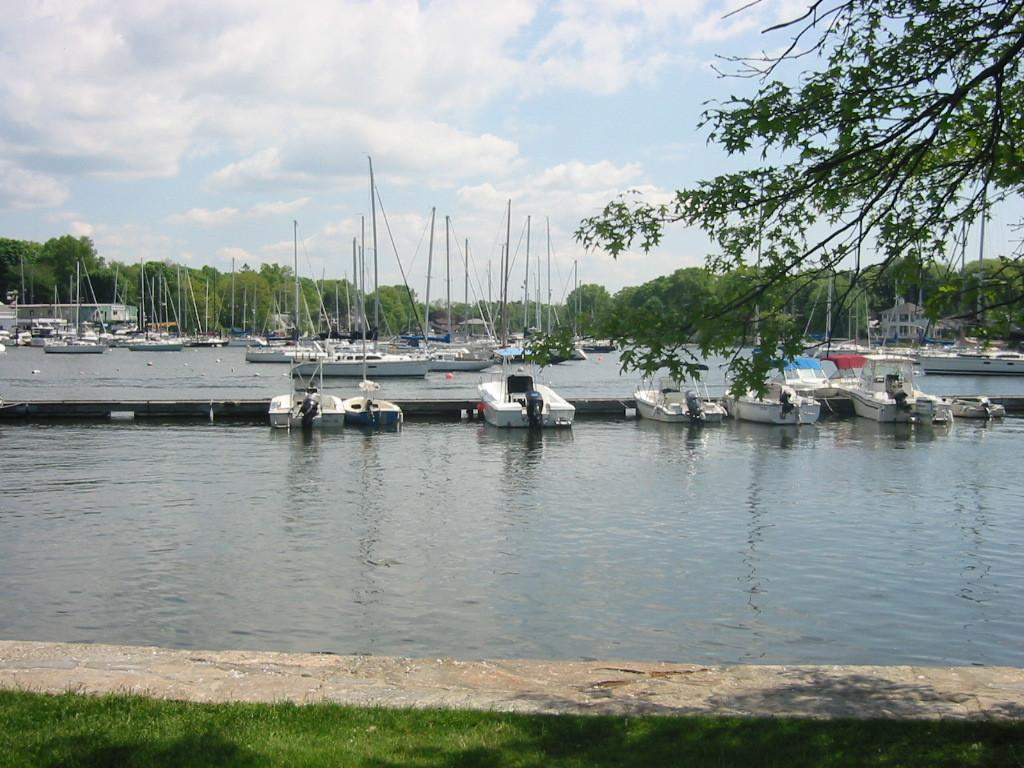What is present at the bottom of the image? There is water at the bottom of the image. What can be seen in the middle of the image? There are boats in the middle of the image. What type of vegetation is visible at the back side of the image? There are trees at the back side of the image. How would you describe the sky in the image? The sky is cloudy at the top of the image. Where are the scissors used for cutting paper in the image? There are no scissors or paper cutting activity present in the image. What type of sport is being played in the image? There is no sport, such as volleyball, depicted in the image. 